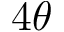Convert formula to latex. <formula><loc_0><loc_0><loc_500><loc_500>4 \theta</formula> 